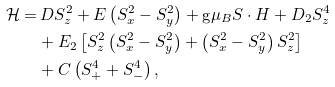Convert formula to latex. <formula><loc_0><loc_0><loc_500><loc_500>\mathcal { H } = & \, D S _ { z } ^ { 2 } + E \left ( S _ { x } ^ { 2 } - S _ { y } ^ { 2 } \right ) + \text {g} \mu _ { B } S \cdot H + D _ { 2 } S _ { z } ^ { 4 } \\ & + E _ { 2 } \left [ S _ { z } ^ { 2 } \left ( S _ { x } ^ { 2 } - S _ { y } ^ { 2 } \right ) + \left ( S _ { x } ^ { 2 } - S _ { y } ^ { 2 } \right ) S _ { z } ^ { 2 } \right ] \\ & + C \left ( S _ { + } ^ { 4 } + S _ { - } ^ { 4 } \right ) ,</formula> 